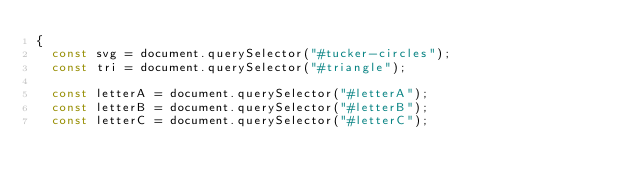Convert code to text. <code><loc_0><loc_0><loc_500><loc_500><_JavaScript_>{
  const svg = document.querySelector("#tucker-circles");
  const tri = document.querySelector("#triangle");

  const letterA = document.querySelector("#letterA");
  const letterB = document.querySelector("#letterB");
  const letterC = document.querySelector("#letterC");</code> 